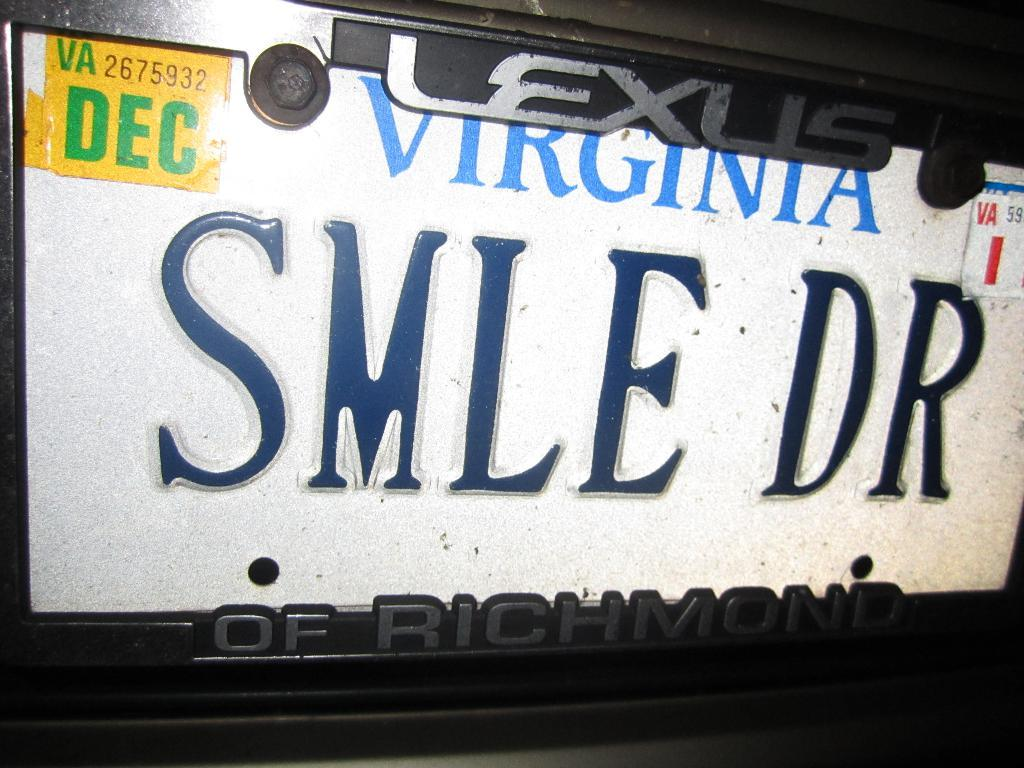Provide a one-sentence caption for the provided image. A Virginia license plate with inspection tags that run out in December. 